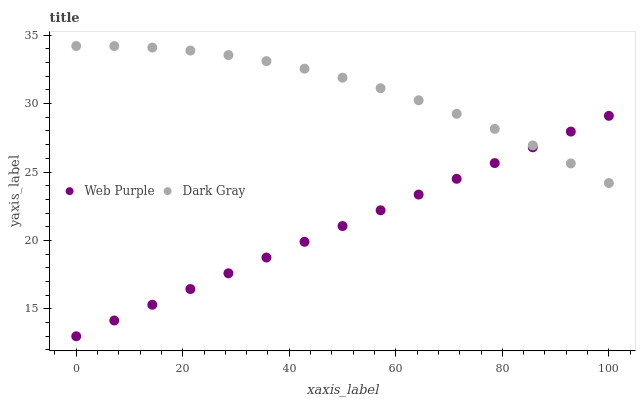Does Web Purple have the minimum area under the curve?
Answer yes or no. Yes. Does Dark Gray have the maximum area under the curve?
Answer yes or no. Yes. Does Web Purple have the maximum area under the curve?
Answer yes or no. No. Is Web Purple the smoothest?
Answer yes or no. Yes. Is Dark Gray the roughest?
Answer yes or no. Yes. Is Web Purple the roughest?
Answer yes or no. No. Does Web Purple have the lowest value?
Answer yes or no. Yes. Does Dark Gray have the highest value?
Answer yes or no. Yes. Does Web Purple have the highest value?
Answer yes or no. No. Does Web Purple intersect Dark Gray?
Answer yes or no. Yes. Is Web Purple less than Dark Gray?
Answer yes or no. No. Is Web Purple greater than Dark Gray?
Answer yes or no. No. 